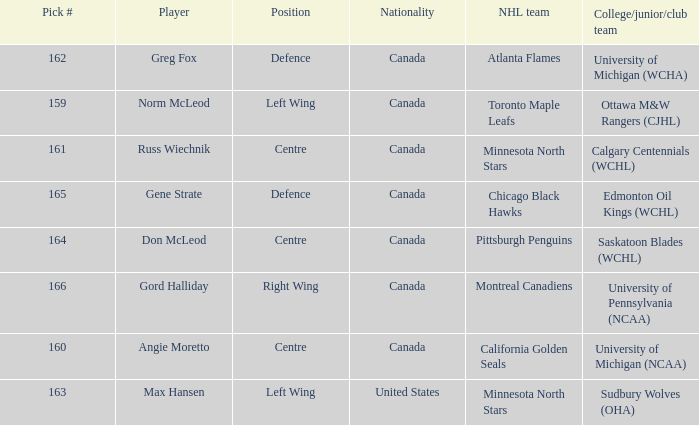What team did Russ Wiechnik, on the centre position, come from? Calgary Centennials (WCHL). Give me the full table as a dictionary. {'header': ['Pick #', 'Player', 'Position', 'Nationality', 'NHL team', 'College/junior/club team'], 'rows': [['162', 'Greg Fox', 'Defence', 'Canada', 'Atlanta Flames', 'University of Michigan (WCHA)'], ['159', 'Norm McLeod', 'Left Wing', 'Canada', 'Toronto Maple Leafs', 'Ottawa M&W Rangers (CJHL)'], ['161', 'Russ Wiechnik', 'Centre', 'Canada', 'Minnesota North Stars', 'Calgary Centennials (WCHL)'], ['165', 'Gene Strate', 'Defence', 'Canada', 'Chicago Black Hawks', 'Edmonton Oil Kings (WCHL)'], ['164', 'Don McLeod', 'Centre', 'Canada', 'Pittsburgh Penguins', 'Saskatoon Blades (WCHL)'], ['166', 'Gord Halliday', 'Right Wing', 'Canada', 'Montreal Canadiens', 'University of Pennsylvania (NCAA)'], ['160', 'Angie Moretto', 'Centre', 'Canada', 'California Golden Seals', 'University of Michigan (NCAA)'], ['163', 'Max Hansen', 'Left Wing', 'United States', 'Minnesota North Stars', 'Sudbury Wolves (OHA)']]} 